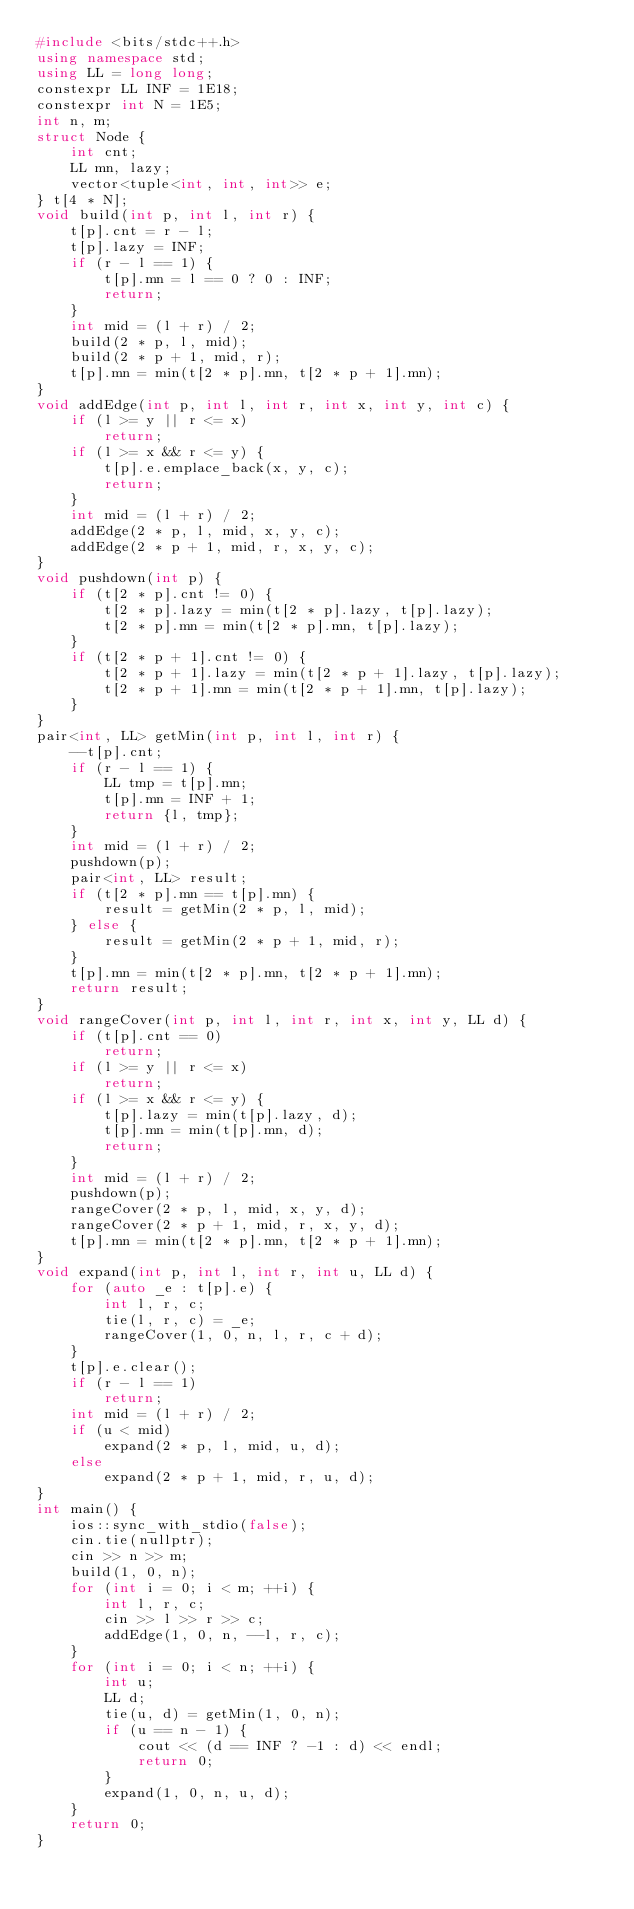<code> <loc_0><loc_0><loc_500><loc_500><_C++_>#include <bits/stdc++.h>
using namespace std;
using LL = long long;
constexpr LL INF = 1E18;
constexpr int N = 1E5;
int n, m;
struct Node {
    int cnt;
    LL mn, lazy;
    vector<tuple<int, int, int>> e;
} t[4 * N];
void build(int p, int l, int r) {
    t[p].cnt = r - l;
    t[p].lazy = INF;
    if (r - l == 1) {
        t[p].mn = l == 0 ? 0 : INF;
        return;
    }
    int mid = (l + r) / 2;
    build(2 * p, l, mid);
    build(2 * p + 1, mid, r);
    t[p].mn = min(t[2 * p].mn, t[2 * p + 1].mn);
}
void addEdge(int p, int l, int r, int x, int y, int c) {
    if (l >= y || r <= x)
        return;
    if (l >= x && r <= y) {
        t[p].e.emplace_back(x, y, c);
        return;
    }
    int mid = (l + r) / 2;
    addEdge(2 * p, l, mid, x, y, c);
    addEdge(2 * p + 1, mid, r, x, y, c);
}
void pushdown(int p) {
    if (t[2 * p].cnt != 0) {
        t[2 * p].lazy = min(t[2 * p].lazy, t[p].lazy);
        t[2 * p].mn = min(t[2 * p].mn, t[p].lazy);
    }
    if (t[2 * p + 1].cnt != 0) {
        t[2 * p + 1].lazy = min(t[2 * p + 1].lazy, t[p].lazy);
        t[2 * p + 1].mn = min(t[2 * p + 1].mn, t[p].lazy);
    }
}
pair<int, LL> getMin(int p, int l, int r) {
    --t[p].cnt;
    if (r - l == 1) {
        LL tmp = t[p].mn;
        t[p].mn = INF + 1;
        return {l, tmp};
    }
    int mid = (l + r) / 2;
    pushdown(p);
    pair<int, LL> result;
    if (t[2 * p].mn == t[p].mn) {
        result = getMin(2 * p, l, mid);
    } else {
        result = getMin(2 * p + 1, mid, r);
    }
    t[p].mn = min(t[2 * p].mn, t[2 * p + 1].mn);
    return result;
}
void rangeCover(int p, int l, int r, int x, int y, LL d) {
    if (t[p].cnt == 0)
        return;
    if (l >= y || r <= x)
        return;
    if (l >= x && r <= y) {
        t[p].lazy = min(t[p].lazy, d);
        t[p].mn = min(t[p].mn, d);
        return;
    }
    int mid = (l + r) / 2;
    pushdown(p);
    rangeCover(2 * p, l, mid, x, y, d);
    rangeCover(2 * p + 1, mid, r, x, y, d);
    t[p].mn = min(t[2 * p].mn, t[2 * p + 1].mn);
}
void expand(int p, int l, int r, int u, LL d) {
    for (auto _e : t[p].e) {
        int l, r, c;
        tie(l, r, c) = _e;
        rangeCover(1, 0, n, l, r, c + d);
    }
    t[p].e.clear();
    if (r - l == 1)
        return;
    int mid = (l + r) / 2;
    if (u < mid)
        expand(2 * p, l, mid, u, d);
    else
        expand(2 * p + 1, mid, r, u, d);
}
int main() {
    ios::sync_with_stdio(false);
    cin.tie(nullptr);
    cin >> n >> m;
    build(1, 0, n);
    for (int i = 0; i < m; ++i) {
        int l, r, c;
        cin >> l >> r >> c;
        addEdge(1, 0, n, --l, r, c);
    }
    for (int i = 0; i < n; ++i) {
        int u;
        LL d;
        tie(u, d) = getMin(1, 0, n);
        if (u == n - 1) {
            cout << (d == INF ? -1 : d) << endl;
            return 0;
        }
        expand(1, 0, n, u, d);
    }
    return 0;
} </code> 